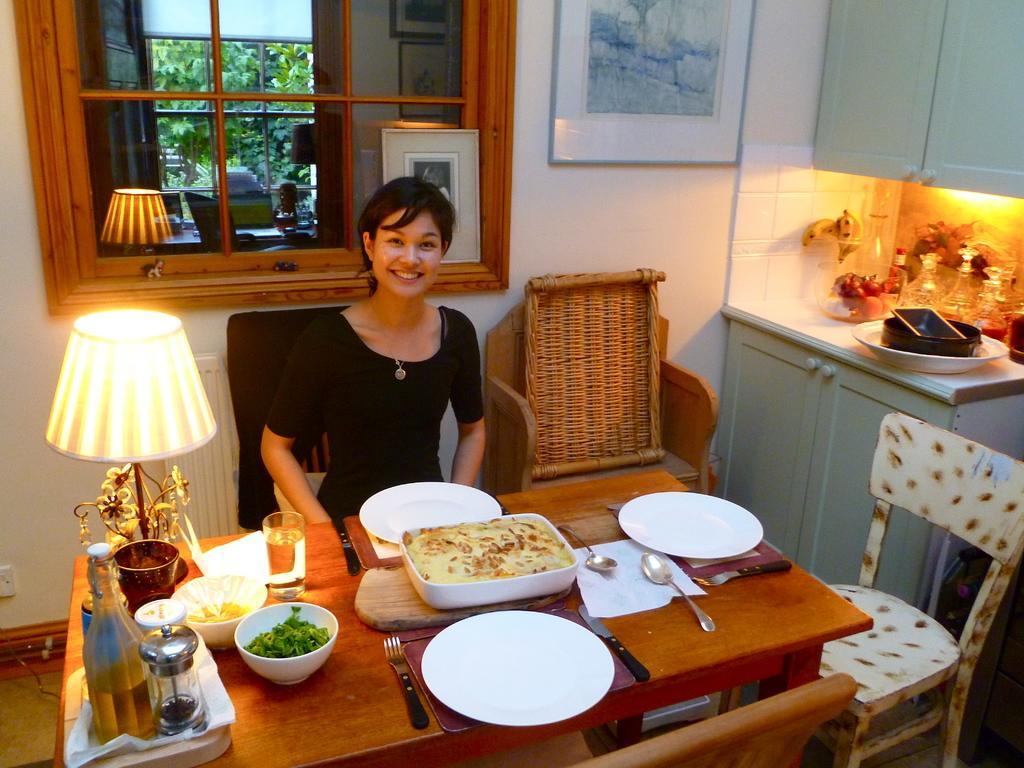Please provide a concise description of this image. In this picture there is a woman sitting and smiling she has a table in front of her with bowl of food plate, spoons and wine glass there is a lamp and in the background is a window, a photo frame on the wall and a extra chair 